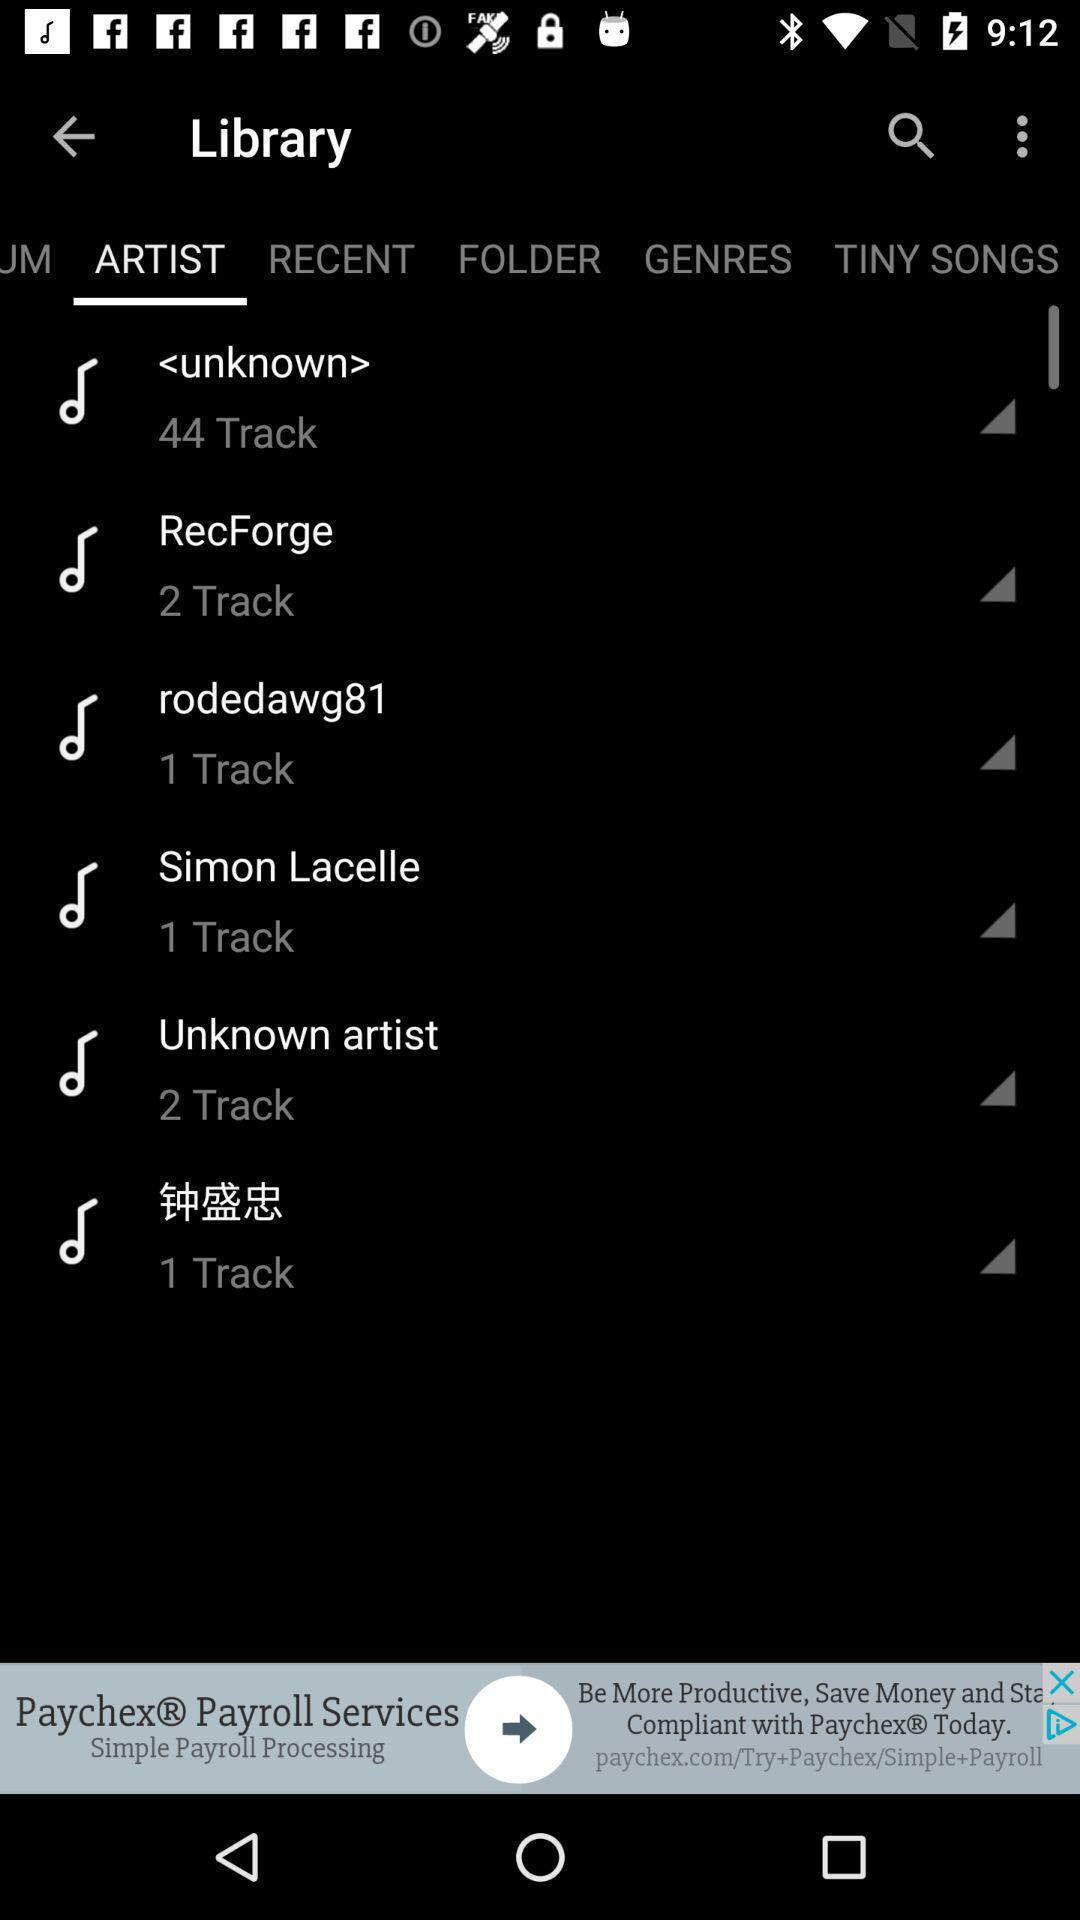What is the number of tracks present in "RecForge"? The number of tracks is 2. 